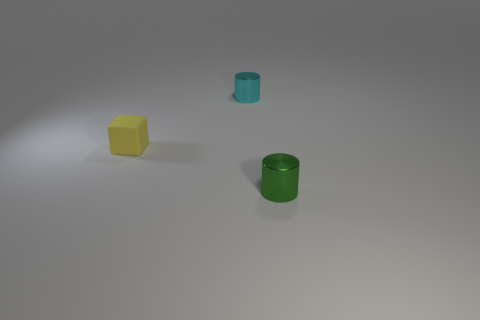Add 2 cyan cylinders. How many objects exist? 5 Subtract all green cylinders. How many cylinders are left? 1 Subtract all cubes. How many objects are left? 2 Subtract 2 cylinders. How many cylinders are left? 0 Subtract 0 purple balls. How many objects are left? 3 Subtract all green cylinders. Subtract all blue spheres. How many cylinders are left? 1 Subtract all purple balls. How many red cylinders are left? 0 Subtract all large purple rubber cylinders. Subtract all tiny metal things. How many objects are left? 1 Add 1 small cyan shiny cylinders. How many small cyan shiny cylinders are left? 2 Add 2 cyan metallic cylinders. How many cyan metallic cylinders exist? 3 